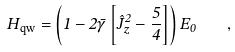<formula> <loc_0><loc_0><loc_500><loc_500>H _ { \text {qw} } = \left ( 1 - 2 \bar { \gamma } \left [ { \hat { J } } _ { z } ^ { 2 } - \frac { 5 } { 4 } \right ] \right ) E _ { 0 } \quad ,</formula> 